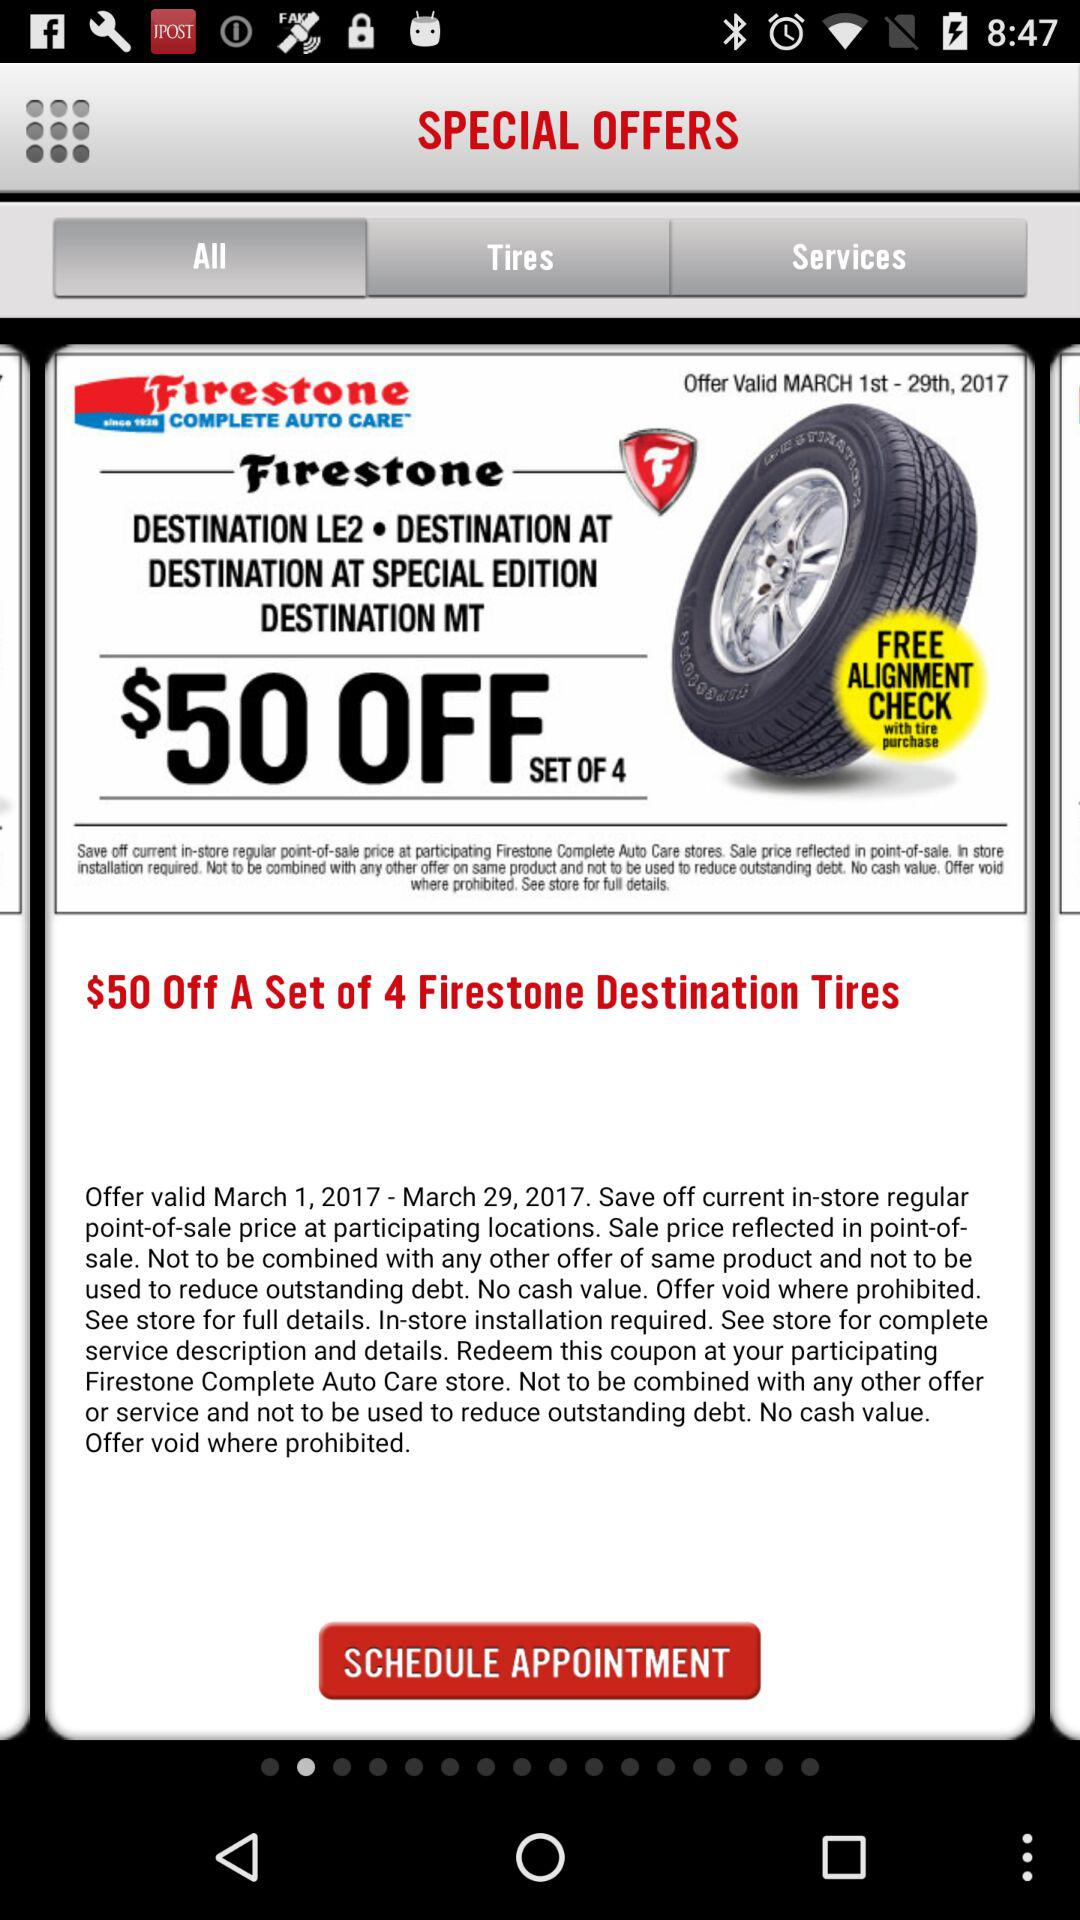How much is off on a set of four "Firestone Destination" tires? There is $50 off on a set of four "Firestone Destination" tires. 